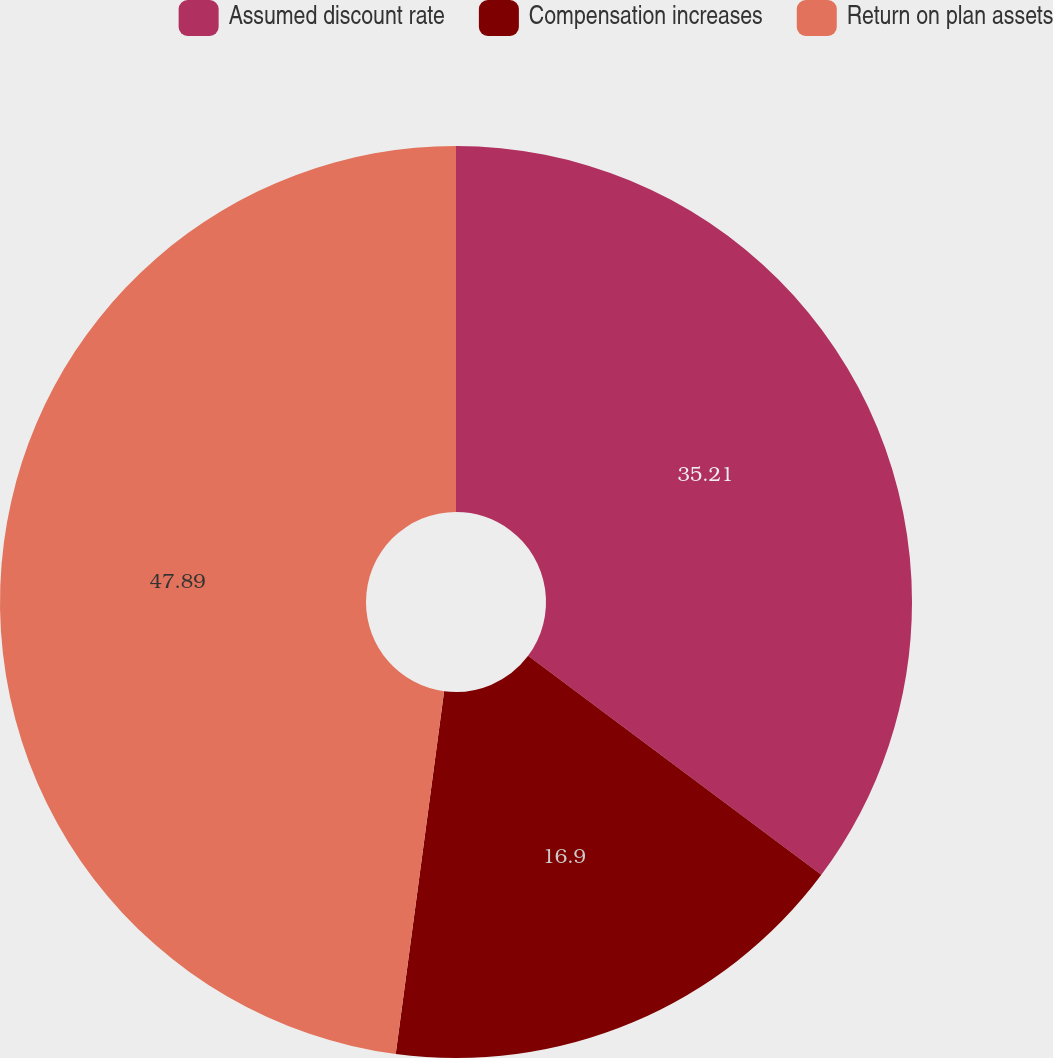<chart> <loc_0><loc_0><loc_500><loc_500><pie_chart><fcel>Assumed discount rate<fcel>Compensation increases<fcel>Return on plan assets<nl><fcel>35.21%<fcel>16.9%<fcel>47.89%<nl></chart> 